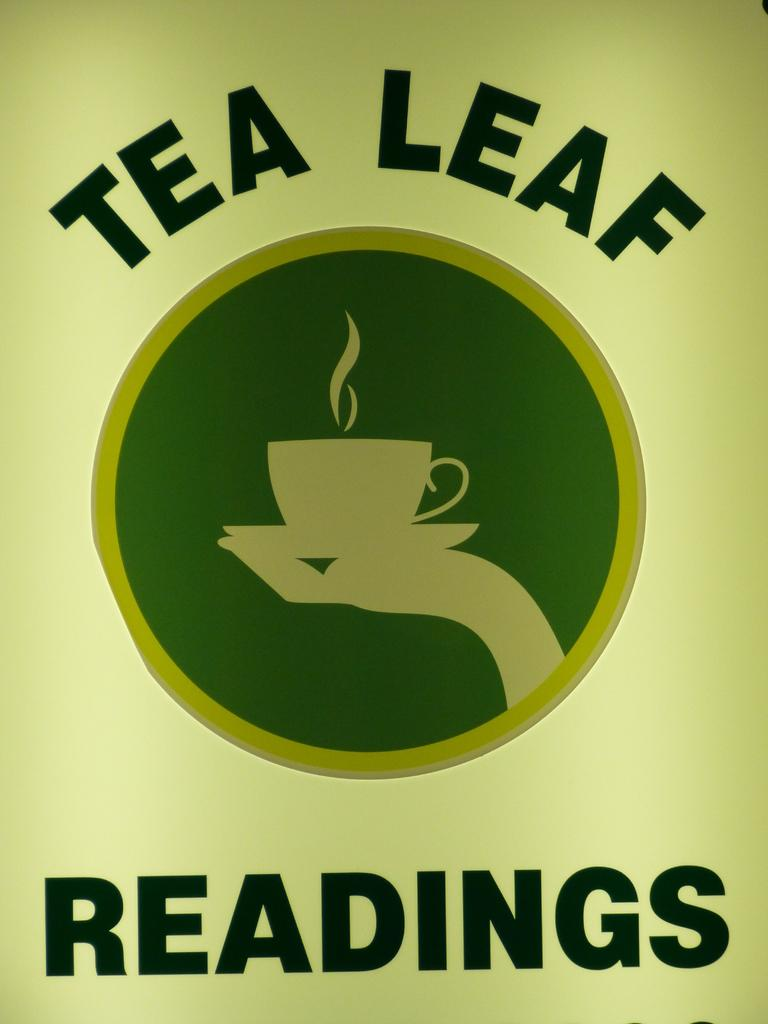<image>
Present a compact description of the photo's key features. an advertisement for tea leaf readings that is green 